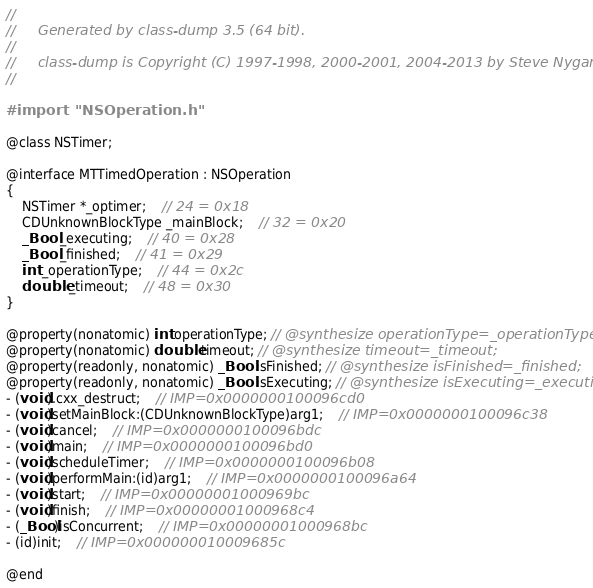Convert code to text. <code><loc_0><loc_0><loc_500><loc_500><_C_>//
//     Generated by class-dump 3.5 (64 bit).
//
//     class-dump is Copyright (C) 1997-1998, 2000-2001, 2004-2013 by Steve Nygard.
//

#import "NSOperation.h"

@class NSTimer;

@interface MTTimedOperation : NSOperation
{
    NSTimer *_optimer;	// 24 = 0x18
    CDUnknownBlockType _mainBlock;	// 32 = 0x20
    _Bool _executing;	// 40 = 0x28
    _Bool _finished;	// 41 = 0x29
    int _operationType;	// 44 = 0x2c
    double _timeout;	// 48 = 0x30
}

@property(nonatomic) int operationType; // @synthesize operationType=_operationType;
@property(nonatomic) double timeout; // @synthesize timeout=_timeout;
@property(readonly, nonatomic) _Bool isFinished; // @synthesize isFinished=_finished;
@property(readonly, nonatomic) _Bool isExecuting; // @synthesize isExecuting=_executing;
- (void).cxx_destruct;	// IMP=0x0000000100096cd0
- (void)setMainBlock:(CDUnknownBlockType)arg1;	// IMP=0x0000000100096c38
- (void)cancel;	// IMP=0x0000000100096bdc
- (void)main;	// IMP=0x0000000100096bd0
- (void)scheduleTimer;	// IMP=0x0000000100096b08
- (void)performMain:(id)arg1;	// IMP=0x0000000100096a64
- (void)start;	// IMP=0x00000001000969bc
- (void)finish;	// IMP=0x00000001000968c4
- (_Bool)isConcurrent;	// IMP=0x00000001000968bc
- (id)init;	// IMP=0x000000010009685c

@end

</code> 